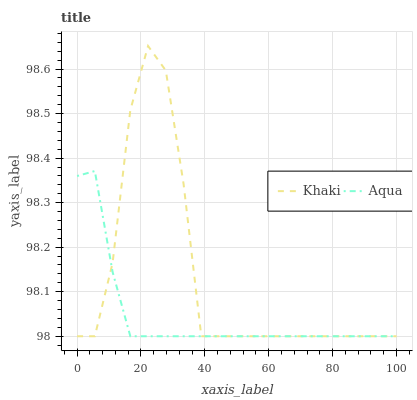Does Aqua have the minimum area under the curve?
Answer yes or no. Yes. Does Khaki have the maximum area under the curve?
Answer yes or no. Yes. Does Aqua have the maximum area under the curve?
Answer yes or no. No. Is Aqua the smoothest?
Answer yes or no. Yes. Is Khaki the roughest?
Answer yes or no. Yes. Is Aqua the roughest?
Answer yes or no. No. Does Khaki have the lowest value?
Answer yes or no. Yes. Does Khaki have the highest value?
Answer yes or no. Yes. Does Aqua have the highest value?
Answer yes or no. No. Does Khaki intersect Aqua?
Answer yes or no. Yes. Is Khaki less than Aqua?
Answer yes or no. No. Is Khaki greater than Aqua?
Answer yes or no. No. 